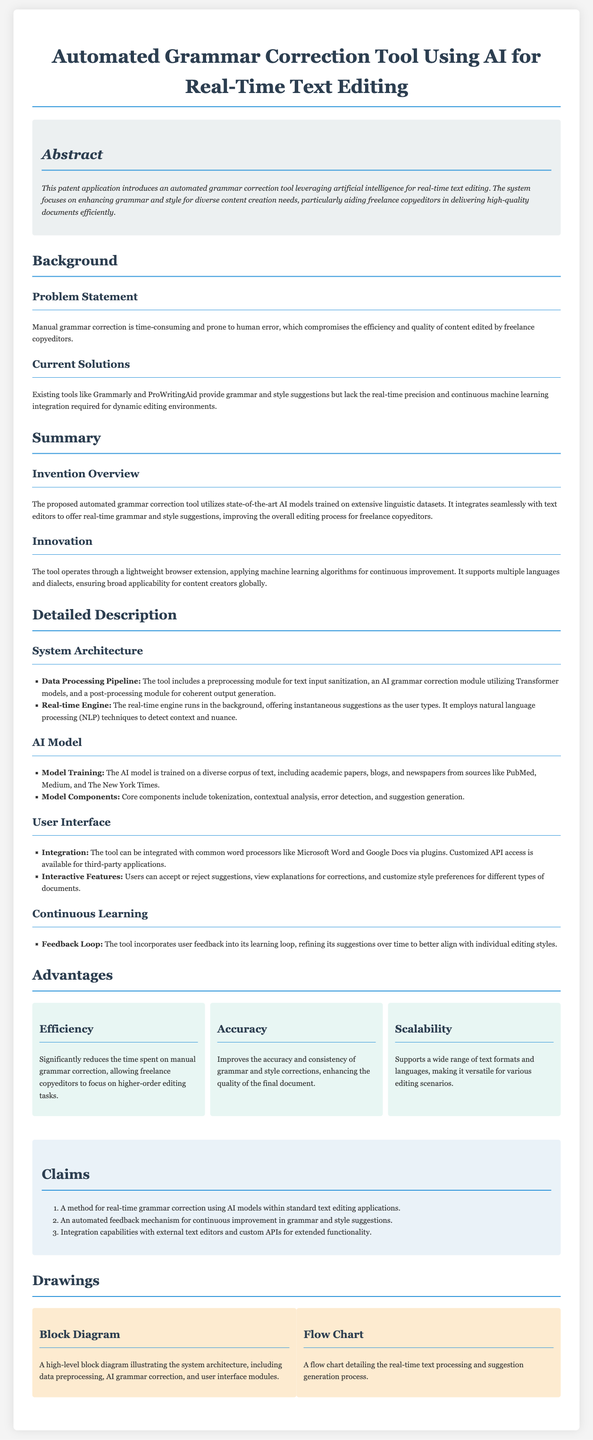What is the title of the patent application? The title of the patent application is prominently displayed at the top of the document.
Answer: Automated Grammar Correction Tool Using AI for Real-Time Text Editing What problem does the invention aim to solve? The document states the problem in the "Problem Statement" section.
Answer: Time-consuming manual grammar correction What existing tools are mentioned as current solutions? The "Current Solutions" section lists existing tools for comparison.
Answer: Grammarly and ProWritingAid What is the main feature of the proposed tool? The "Invention Overview" outlines the tool's main feature.
Answer: Real-time grammar and style suggestions What are the three components of the AI model mentioned? The "Model Components" subsection lists the key elements of the AI model.
Answer: Tokenization, contextual analysis, error detection, and suggestion generation What advantage does the tool provide regarding editing tasks? The "Efficiency" advantage explains how the tool helps copyeditors.
Answer: Reduces time spent on manual grammar correction How many claims does the patent make? The "Claims" section provides a numbered list of claims.
Answer: Three What type of integration capabilities does the tool have? The "Integration" subsection within the user interface section describes this capability.
Answer: Integration with common word processors like Microsoft Word and Google Docs What is the primary benefit of the feedback loop mentioned in the document? The "Continuous Learning" section describes the function of the feedback loop.
Answer: Refines suggestions over time 